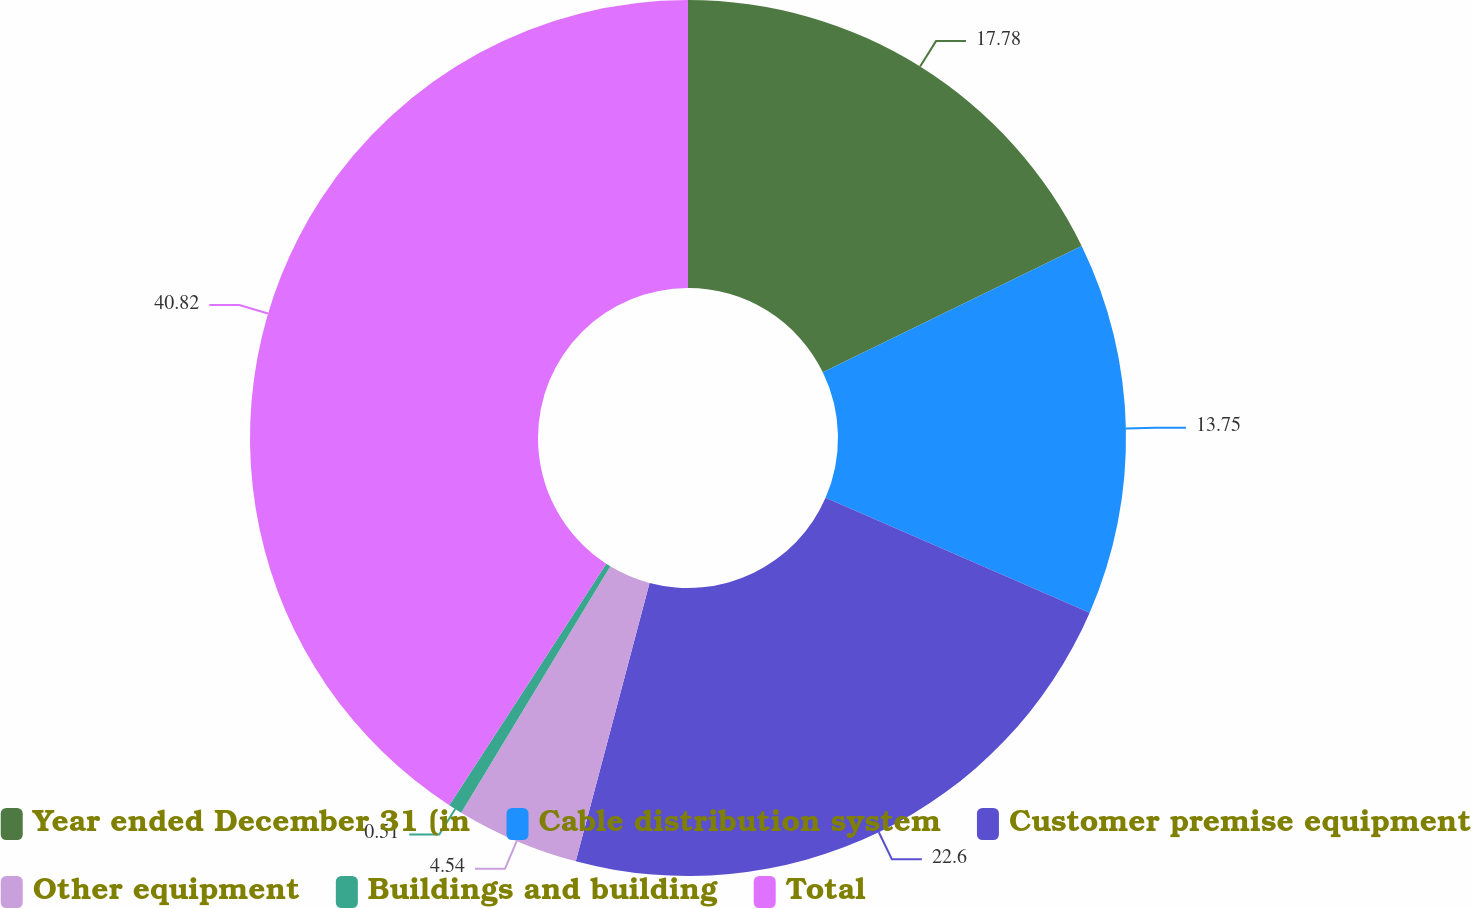<chart> <loc_0><loc_0><loc_500><loc_500><pie_chart><fcel>Year ended December 31 (in<fcel>Cable distribution system<fcel>Customer premise equipment<fcel>Other equipment<fcel>Buildings and building<fcel>Total<nl><fcel>17.78%<fcel>13.75%<fcel>22.6%<fcel>4.54%<fcel>0.51%<fcel>40.83%<nl></chart> 